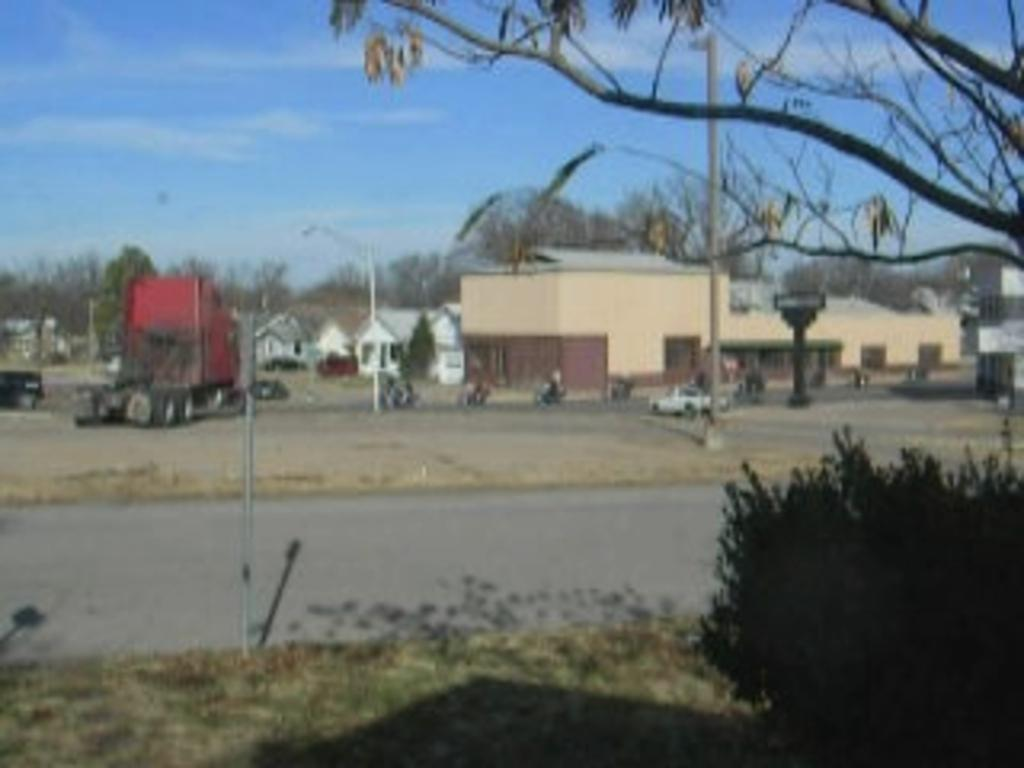What type of structures can be seen in the image? There are buildings in the image. What other natural elements are present in the image? There are trees in the image. What types of man-made objects can be seen on the ground in the image? There are vehicles on the ground in the image. What are the tall, thin structures in the image? There are light poles in the image. What is the pole with a board used for in the image? The pole with a board might be used for displaying information or advertisements. What can be seen in the background of the image? The sky is visible in the background of the image. What type of cow can be seen grazing in the image? There is no cow present in the image. What is the texture of the throat of the person in the image? There is no person present in the image, so it is not possible to determine the texture of their throat. 